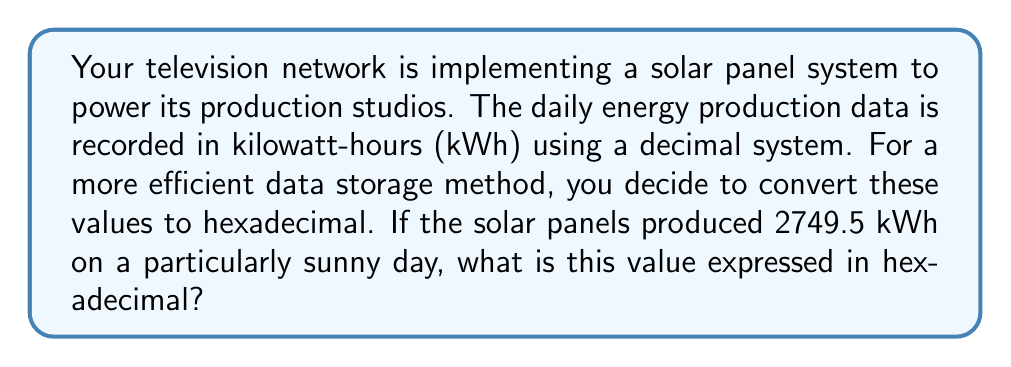Solve this math problem. To convert 2749.5 from decimal to hexadecimal, we need to handle the integer and fractional parts separately.

1. Convert the integer part (2749):
   $2749 \div 16 = 171$ remainder $13$ (D in hex)
   $171 \div 16 = 10$ remainder $11$ (B in hex)
   $10 \div 16 = 0$ remainder $10$ (A in hex)

   So, 2749 in hexadecimal is ABD.

2. Convert the fractional part (0.5):
   $0.5 \times 16 = 8$ (whole number part)

   The fractional part conversion stops here as we get a whole number.

3. Combine the results:
   2749.5 in hexadecimal is ABD.8

Therefore, the solar panel energy production of 2749.5 kWh in decimal is equivalent to ABD.8 kWh in hexadecimal.
Answer: ABD.8 